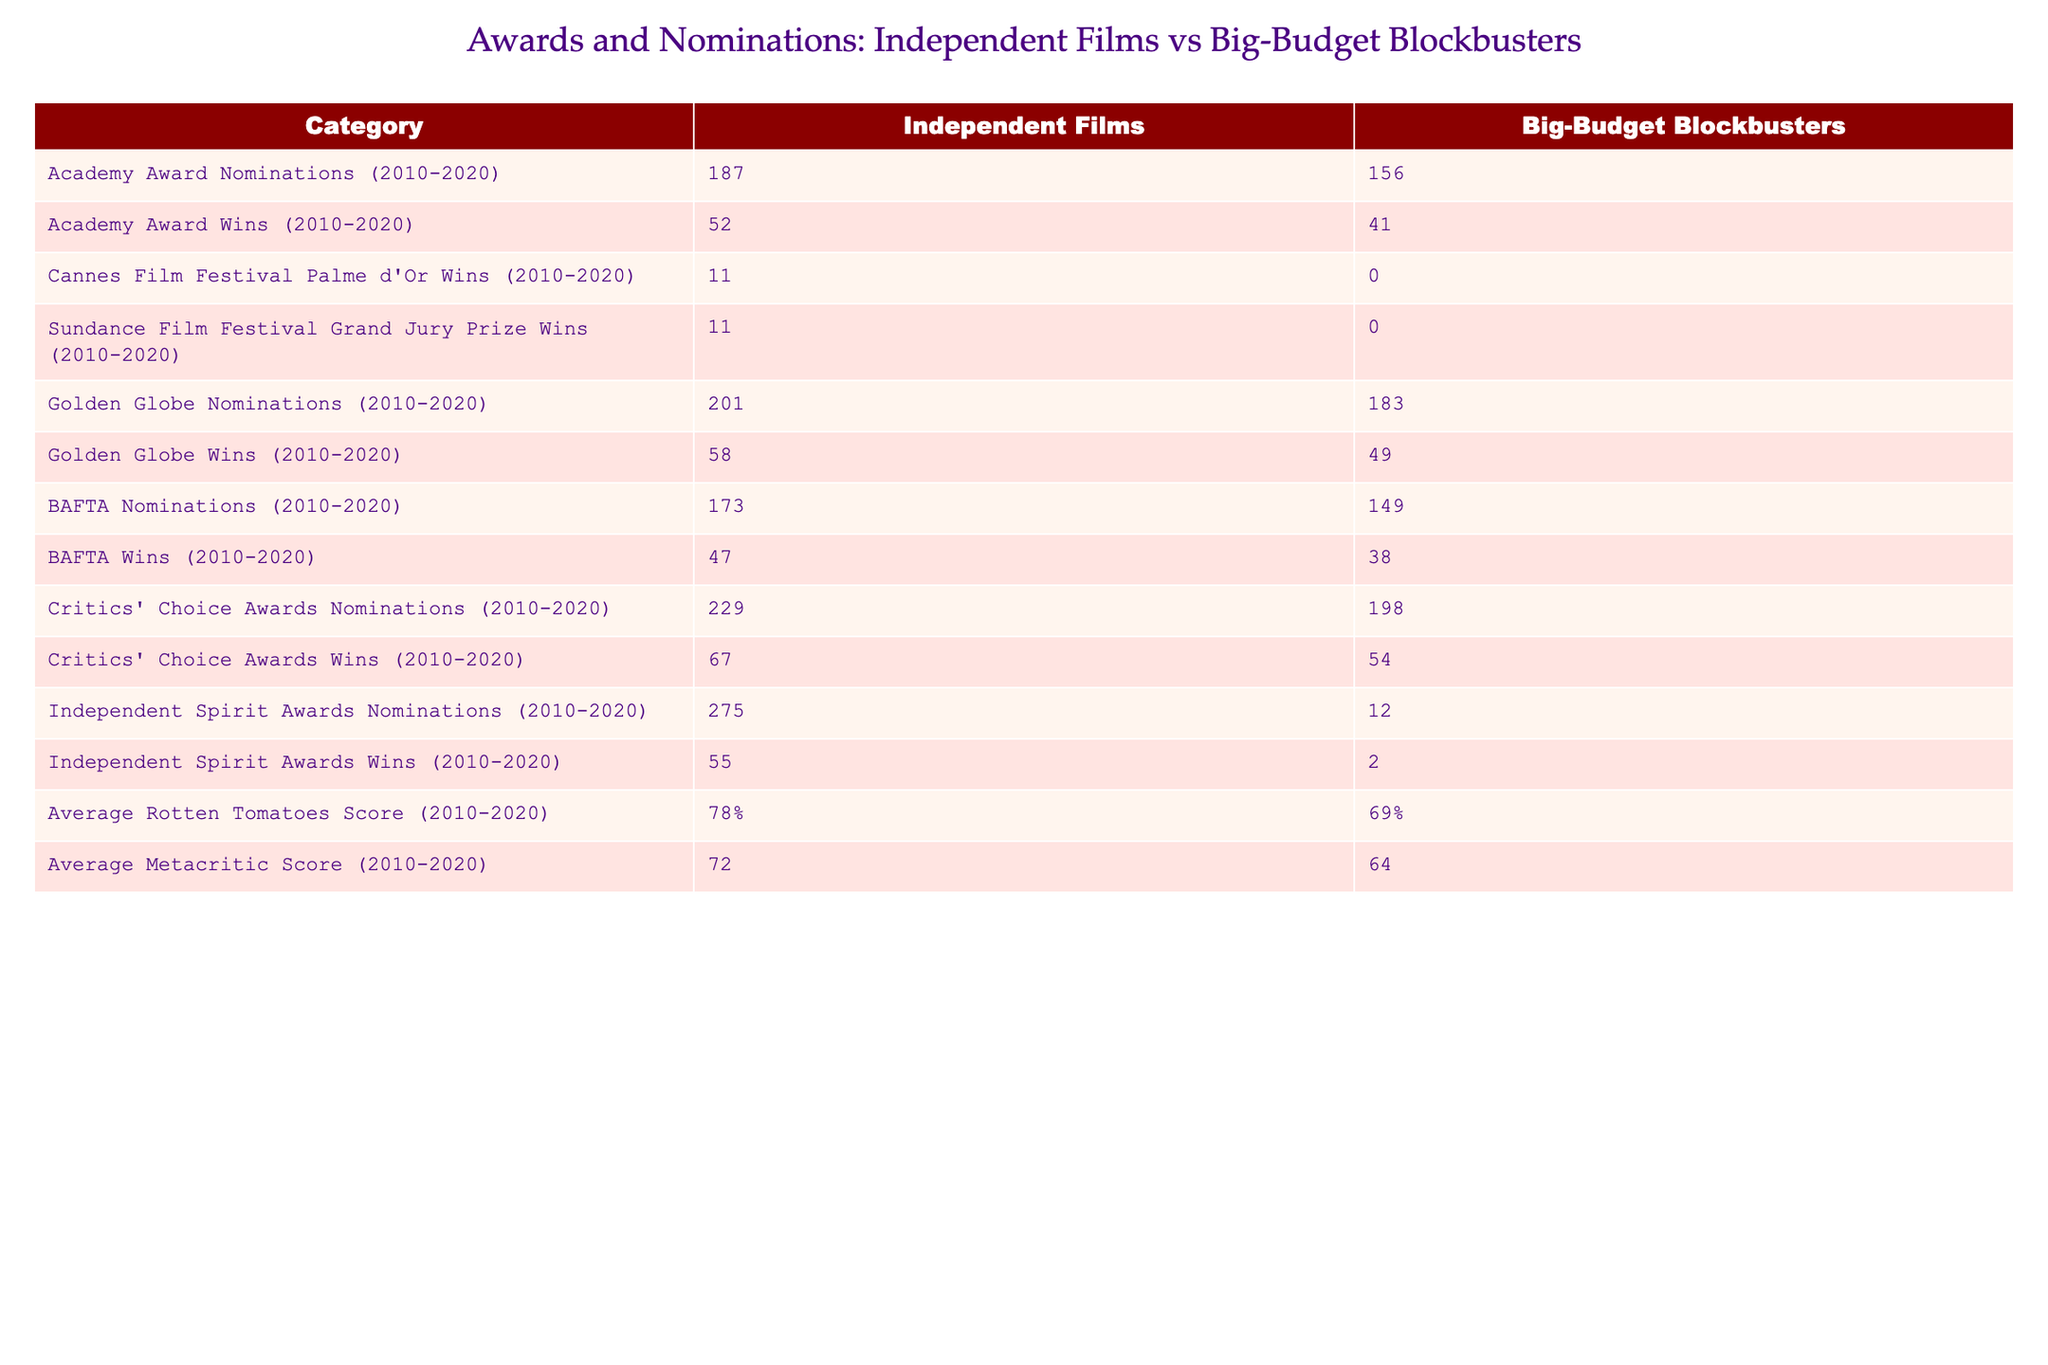What is the total number of Academy Award Nominations for Independent Films from 2010 to 2020? The table shows that Independent Films received 187 Academy Award Nominations between 2010 and 2020.
Answer: 187 How many more Academy Award Wins did Independent Films have compared to Big-Budget Blockbusters from 2010 to 2020? Independent Films won 52 Academy Awards while Big-Budget Blockbusters won 41. The difference is 52 - 41 = 11.
Answer: 11 Did Big-Budget Blockbusters win any Cannes Film Festival Palme d'Or Awards from 2010 to 2020? According to the table, Big-Budget Blockbusters did not win any Palme d'Or Awards, as the count is 0.
Answer: No What are the average Rotten Tomatoes Scores for Independent Films and Big-Budget Blockbusters from 2010 to 2020? The table shows that Independent Films received an average score of 78%, and Big-Budget Blockbusters received 69%.
Answer: 78% for Independent Films, 69% for Big-Budget Blockbusters How many more Critics' Choice Awards Nominations did Independent Films receive than Big-Budget Blockbusters from 2010 to 2020? Independent Films had 229 nominations while Big-Budget Blockbusters had 198. The difference is 229 - 198 = 31.
Answer: 31 Is the average Metacritic Score for Independent Films higher than that of Big-Budget Blockbusters? The average Metacritic Score for Independent Films is 72 while it is 64 for Big-Budget Blockbusters. Since 72 > 64, the statement is true.
Answer: Yes What is the total number of Independent Spirit Awards Wins compared to Big-Budget Blockbusters? Independent Films won 55 Independent Spirit Awards, and Big-Budget Blockbusters won 2. The total for Independent Films is 55, while for Big-Budget Blockbusters it is 2.
Answer: Independent Films: 55, Big-Budget Blockbusters: 2 If you add both Academy Award Nominations for Independent Films and Big-Budget Blockbusters, what is the sum? Independent Films had 187 nominations and Big-Budget Blockbusters had 156. Adding them gives 187 + 156 = 343.
Answer: 343 Which category shows the greatest disparity in wins between Independent Films and Big-Budget Blockbusters? The Independent Spirit Awards Show a significant disparity with Independent Films winning 55 and Big-Budget Blockbusters only winning 2, a difference of 53.
Answer: Independent Spirit Awards Calculate the percentage of Academy Award Wins out of Academy Award Nominations for Independent Films versus Big-Budget Blockbusters. For Independent Films, the percentage is (52 wins / 187 nominations) * 100 ≈ 27.8%. For Big-Budget Blockbusters, it is (41 wins / 156 nominations) * 100 ≈ 26.3%.
Answer: 27.8% for Independent Films, 26.3% for Big-Budget Blockbusters 